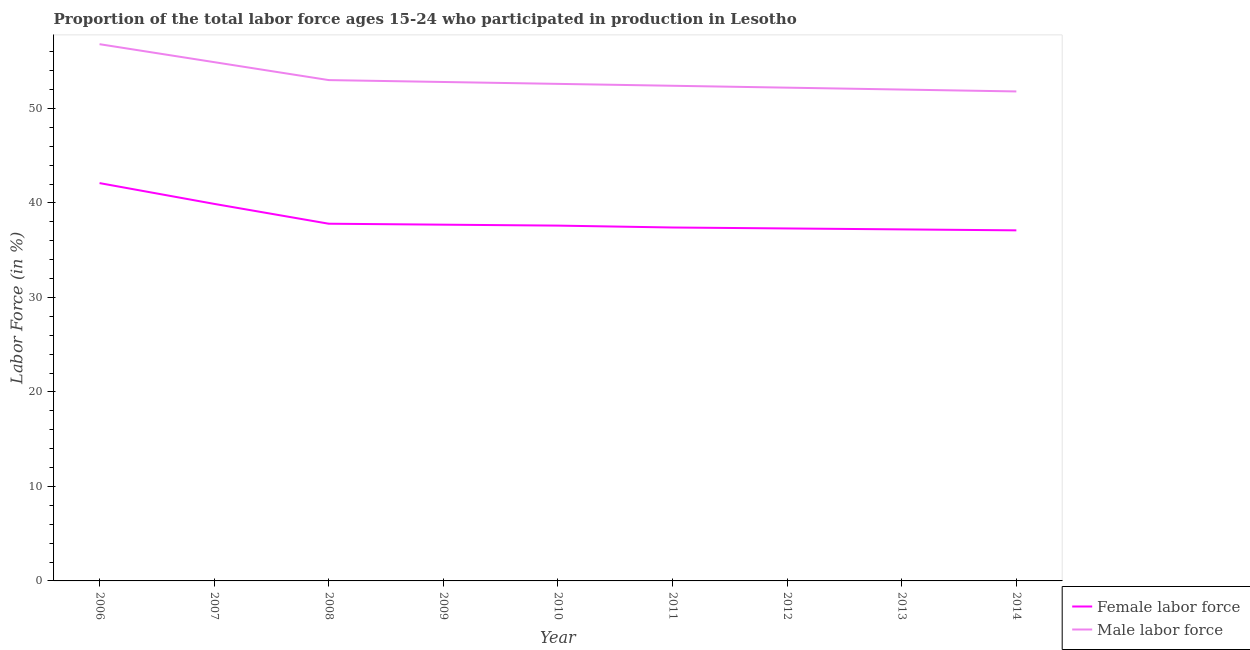Does the line corresponding to percentage of male labour force intersect with the line corresponding to percentage of female labor force?
Keep it short and to the point. No. What is the percentage of female labor force in 2010?
Your answer should be compact. 37.6. Across all years, what is the maximum percentage of female labor force?
Make the answer very short. 42.1. Across all years, what is the minimum percentage of female labor force?
Your answer should be compact. 37.1. In which year was the percentage of female labor force minimum?
Provide a short and direct response. 2014. What is the total percentage of male labour force in the graph?
Make the answer very short. 478.5. What is the difference between the percentage of male labour force in 2006 and that in 2011?
Provide a succinct answer. 4.4. What is the difference between the percentage of female labor force in 2011 and the percentage of male labour force in 2012?
Offer a terse response. -14.8. What is the average percentage of male labour force per year?
Provide a succinct answer. 53.17. In the year 2009, what is the difference between the percentage of male labour force and percentage of female labor force?
Your answer should be very brief. 15.1. In how many years, is the percentage of male labour force greater than 46 %?
Your answer should be very brief. 9. What is the ratio of the percentage of female labor force in 2010 to that in 2012?
Offer a very short reply. 1.01. Is the percentage of male labour force in 2008 less than that in 2010?
Make the answer very short. No. Is the difference between the percentage of male labour force in 2008 and 2013 greater than the difference between the percentage of female labor force in 2008 and 2013?
Your answer should be very brief. Yes. What is the difference between the highest and the second highest percentage of female labor force?
Offer a terse response. 2.2. How many years are there in the graph?
Offer a terse response. 9. Are the values on the major ticks of Y-axis written in scientific E-notation?
Offer a terse response. No. Does the graph contain any zero values?
Provide a succinct answer. No. Does the graph contain grids?
Your answer should be compact. No. Where does the legend appear in the graph?
Your response must be concise. Bottom right. What is the title of the graph?
Offer a terse response. Proportion of the total labor force ages 15-24 who participated in production in Lesotho. What is the label or title of the X-axis?
Keep it short and to the point. Year. What is the label or title of the Y-axis?
Provide a short and direct response. Labor Force (in %). What is the Labor Force (in %) of Female labor force in 2006?
Offer a very short reply. 42.1. What is the Labor Force (in %) of Male labor force in 2006?
Provide a succinct answer. 56.8. What is the Labor Force (in %) of Female labor force in 2007?
Provide a succinct answer. 39.9. What is the Labor Force (in %) in Male labor force in 2007?
Ensure brevity in your answer.  54.9. What is the Labor Force (in %) in Female labor force in 2008?
Make the answer very short. 37.8. What is the Labor Force (in %) in Male labor force in 2008?
Provide a succinct answer. 53. What is the Labor Force (in %) of Female labor force in 2009?
Make the answer very short. 37.7. What is the Labor Force (in %) of Male labor force in 2009?
Your response must be concise. 52.8. What is the Labor Force (in %) in Female labor force in 2010?
Make the answer very short. 37.6. What is the Labor Force (in %) in Male labor force in 2010?
Give a very brief answer. 52.6. What is the Labor Force (in %) in Female labor force in 2011?
Keep it short and to the point. 37.4. What is the Labor Force (in %) of Male labor force in 2011?
Provide a short and direct response. 52.4. What is the Labor Force (in %) of Female labor force in 2012?
Your answer should be compact. 37.3. What is the Labor Force (in %) in Male labor force in 2012?
Ensure brevity in your answer.  52.2. What is the Labor Force (in %) in Female labor force in 2013?
Ensure brevity in your answer.  37.2. What is the Labor Force (in %) in Female labor force in 2014?
Provide a short and direct response. 37.1. What is the Labor Force (in %) in Male labor force in 2014?
Offer a terse response. 51.8. Across all years, what is the maximum Labor Force (in %) of Female labor force?
Keep it short and to the point. 42.1. Across all years, what is the maximum Labor Force (in %) of Male labor force?
Your answer should be very brief. 56.8. Across all years, what is the minimum Labor Force (in %) in Female labor force?
Keep it short and to the point. 37.1. Across all years, what is the minimum Labor Force (in %) of Male labor force?
Provide a short and direct response. 51.8. What is the total Labor Force (in %) of Female labor force in the graph?
Make the answer very short. 344.1. What is the total Labor Force (in %) in Male labor force in the graph?
Ensure brevity in your answer.  478.5. What is the difference between the Labor Force (in %) of Female labor force in 2006 and that in 2007?
Your answer should be compact. 2.2. What is the difference between the Labor Force (in %) of Male labor force in 2006 and that in 2007?
Your response must be concise. 1.9. What is the difference between the Labor Force (in %) of Male labor force in 2006 and that in 2008?
Offer a very short reply. 3.8. What is the difference between the Labor Force (in %) of Male labor force in 2006 and that in 2009?
Your answer should be compact. 4. What is the difference between the Labor Force (in %) in Male labor force in 2006 and that in 2012?
Provide a short and direct response. 4.6. What is the difference between the Labor Force (in %) of Male labor force in 2006 and that in 2013?
Provide a succinct answer. 4.8. What is the difference between the Labor Force (in %) of Female labor force in 2006 and that in 2014?
Your response must be concise. 5. What is the difference between the Labor Force (in %) of Male labor force in 2007 and that in 2008?
Ensure brevity in your answer.  1.9. What is the difference between the Labor Force (in %) of Female labor force in 2007 and that in 2010?
Your answer should be very brief. 2.3. What is the difference between the Labor Force (in %) of Male labor force in 2007 and that in 2010?
Your answer should be compact. 2.3. What is the difference between the Labor Force (in %) in Male labor force in 2007 and that in 2011?
Offer a very short reply. 2.5. What is the difference between the Labor Force (in %) of Female labor force in 2007 and that in 2012?
Make the answer very short. 2.6. What is the difference between the Labor Force (in %) of Female labor force in 2007 and that in 2013?
Provide a short and direct response. 2.7. What is the difference between the Labor Force (in %) of Male labor force in 2007 and that in 2013?
Provide a short and direct response. 2.9. What is the difference between the Labor Force (in %) of Male labor force in 2007 and that in 2014?
Ensure brevity in your answer.  3.1. What is the difference between the Labor Force (in %) in Female labor force in 2008 and that in 2009?
Your answer should be very brief. 0.1. What is the difference between the Labor Force (in %) of Male labor force in 2008 and that in 2009?
Ensure brevity in your answer.  0.2. What is the difference between the Labor Force (in %) of Female labor force in 2008 and that in 2010?
Provide a succinct answer. 0.2. What is the difference between the Labor Force (in %) in Male labor force in 2008 and that in 2011?
Make the answer very short. 0.6. What is the difference between the Labor Force (in %) of Female labor force in 2008 and that in 2012?
Make the answer very short. 0.5. What is the difference between the Labor Force (in %) of Male labor force in 2008 and that in 2014?
Your response must be concise. 1.2. What is the difference between the Labor Force (in %) in Female labor force in 2009 and that in 2011?
Make the answer very short. 0.3. What is the difference between the Labor Force (in %) of Female labor force in 2009 and that in 2012?
Provide a succinct answer. 0.4. What is the difference between the Labor Force (in %) in Female labor force in 2009 and that in 2013?
Your answer should be very brief. 0.5. What is the difference between the Labor Force (in %) in Female labor force in 2009 and that in 2014?
Ensure brevity in your answer.  0.6. What is the difference between the Labor Force (in %) of Male labor force in 2009 and that in 2014?
Provide a short and direct response. 1. What is the difference between the Labor Force (in %) in Female labor force in 2010 and that in 2011?
Give a very brief answer. 0.2. What is the difference between the Labor Force (in %) in Female labor force in 2010 and that in 2013?
Your response must be concise. 0.4. What is the difference between the Labor Force (in %) in Male labor force in 2010 and that in 2013?
Your answer should be compact. 0.6. What is the difference between the Labor Force (in %) of Male labor force in 2011 and that in 2012?
Your answer should be very brief. 0.2. What is the difference between the Labor Force (in %) in Male labor force in 2011 and that in 2013?
Make the answer very short. 0.4. What is the difference between the Labor Force (in %) in Female labor force in 2011 and that in 2014?
Offer a very short reply. 0.3. What is the difference between the Labor Force (in %) of Male labor force in 2012 and that in 2013?
Give a very brief answer. 0.2. What is the difference between the Labor Force (in %) in Female labor force in 2013 and that in 2014?
Offer a terse response. 0.1. What is the difference between the Labor Force (in %) in Female labor force in 2006 and the Labor Force (in %) in Male labor force in 2007?
Keep it short and to the point. -12.8. What is the difference between the Labor Force (in %) of Female labor force in 2006 and the Labor Force (in %) of Male labor force in 2008?
Keep it short and to the point. -10.9. What is the difference between the Labor Force (in %) in Female labor force in 2006 and the Labor Force (in %) in Male labor force in 2011?
Make the answer very short. -10.3. What is the difference between the Labor Force (in %) in Female labor force in 2006 and the Labor Force (in %) in Male labor force in 2013?
Provide a succinct answer. -9.9. What is the difference between the Labor Force (in %) of Female labor force in 2006 and the Labor Force (in %) of Male labor force in 2014?
Your response must be concise. -9.7. What is the difference between the Labor Force (in %) of Female labor force in 2007 and the Labor Force (in %) of Male labor force in 2008?
Offer a terse response. -13.1. What is the difference between the Labor Force (in %) of Female labor force in 2007 and the Labor Force (in %) of Male labor force in 2009?
Keep it short and to the point. -12.9. What is the difference between the Labor Force (in %) of Female labor force in 2007 and the Labor Force (in %) of Male labor force in 2012?
Provide a succinct answer. -12.3. What is the difference between the Labor Force (in %) in Female labor force in 2007 and the Labor Force (in %) in Male labor force in 2013?
Give a very brief answer. -12.1. What is the difference between the Labor Force (in %) of Female labor force in 2008 and the Labor Force (in %) of Male labor force in 2009?
Keep it short and to the point. -15. What is the difference between the Labor Force (in %) of Female labor force in 2008 and the Labor Force (in %) of Male labor force in 2010?
Your answer should be very brief. -14.8. What is the difference between the Labor Force (in %) of Female labor force in 2008 and the Labor Force (in %) of Male labor force in 2011?
Give a very brief answer. -14.6. What is the difference between the Labor Force (in %) of Female labor force in 2008 and the Labor Force (in %) of Male labor force in 2012?
Your response must be concise. -14.4. What is the difference between the Labor Force (in %) of Female labor force in 2008 and the Labor Force (in %) of Male labor force in 2013?
Provide a succinct answer. -14.2. What is the difference between the Labor Force (in %) in Female labor force in 2009 and the Labor Force (in %) in Male labor force in 2010?
Your response must be concise. -14.9. What is the difference between the Labor Force (in %) in Female labor force in 2009 and the Labor Force (in %) in Male labor force in 2011?
Your answer should be compact. -14.7. What is the difference between the Labor Force (in %) of Female labor force in 2009 and the Labor Force (in %) of Male labor force in 2013?
Keep it short and to the point. -14.3. What is the difference between the Labor Force (in %) in Female labor force in 2009 and the Labor Force (in %) in Male labor force in 2014?
Your answer should be compact. -14.1. What is the difference between the Labor Force (in %) in Female labor force in 2010 and the Labor Force (in %) in Male labor force in 2011?
Keep it short and to the point. -14.8. What is the difference between the Labor Force (in %) in Female labor force in 2010 and the Labor Force (in %) in Male labor force in 2012?
Your response must be concise. -14.6. What is the difference between the Labor Force (in %) in Female labor force in 2010 and the Labor Force (in %) in Male labor force in 2013?
Offer a terse response. -14.4. What is the difference between the Labor Force (in %) in Female labor force in 2010 and the Labor Force (in %) in Male labor force in 2014?
Provide a succinct answer. -14.2. What is the difference between the Labor Force (in %) in Female labor force in 2011 and the Labor Force (in %) in Male labor force in 2012?
Provide a short and direct response. -14.8. What is the difference between the Labor Force (in %) of Female labor force in 2011 and the Labor Force (in %) of Male labor force in 2013?
Ensure brevity in your answer.  -14.6. What is the difference between the Labor Force (in %) in Female labor force in 2011 and the Labor Force (in %) in Male labor force in 2014?
Offer a very short reply. -14.4. What is the difference between the Labor Force (in %) in Female labor force in 2012 and the Labor Force (in %) in Male labor force in 2013?
Give a very brief answer. -14.7. What is the difference between the Labor Force (in %) of Female labor force in 2013 and the Labor Force (in %) of Male labor force in 2014?
Your response must be concise. -14.6. What is the average Labor Force (in %) of Female labor force per year?
Your answer should be compact. 38.23. What is the average Labor Force (in %) of Male labor force per year?
Keep it short and to the point. 53.17. In the year 2006, what is the difference between the Labor Force (in %) in Female labor force and Labor Force (in %) in Male labor force?
Give a very brief answer. -14.7. In the year 2007, what is the difference between the Labor Force (in %) of Female labor force and Labor Force (in %) of Male labor force?
Provide a short and direct response. -15. In the year 2008, what is the difference between the Labor Force (in %) in Female labor force and Labor Force (in %) in Male labor force?
Your answer should be compact. -15.2. In the year 2009, what is the difference between the Labor Force (in %) in Female labor force and Labor Force (in %) in Male labor force?
Your response must be concise. -15.1. In the year 2010, what is the difference between the Labor Force (in %) in Female labor force and Labor Force (in %) in Male labor force?
Make the answer very short. -15. In the year 2012, what is the difference between the Labor Force (in %) in Female labor force and Labor Force (in %) in Male labor force?
Ensure brevity in your answer.  -14.9. In the year 2013, what is the difference between the Labor Force (in %) of Female labor force and Labor Force (in %) of Male labor force?
Your answer should be very brief. -14.8. In the year 2014, what is the difference between the Labor Force (in %) of Female labor force and Labor Force (in %) of Male labor force?
Your answer should be very brief. -14.7. What is the ratio of the Labor Force (in %) of Female labor force in 2006 to that in 2007?
Your response must be concise. 1.06. What is the ratio of the Labor Force (in %) of Male labor force in 2006 to that in 2007?
Offer a terse response. 1.03. What is the ratio of the Labor Force (in %) in Female labor force in 2006 to that in 2008?
Ensure brevity in your answer.  1.11. What is the ratio of the Labor Force (in %) of Male labor force in 2006 to that in 2008?
Your answer should be compact. 1.07. What is the ratio of the Labor Force (in %) of Female labor force in 2006 to that in 2009?
Keep it short and to the point. 1.12. What is the ratio of the Labor Force (in %) in Male labor force in 2006 to that in 2009?
Provide a short and direct response. 1.08. What is the ratio of the Labor Force (in %) of Female labor force in 2006 to that in 2010?
Give a very brief answer. 1.12. What is the ratio of the Labor Force (in %) of Male labor force in 2006 to that in 2010?
Keep it short and to the point. 1.08. What is the ratio of the Labor Force (in %) in Female labor force in 2006 to that in 2011?
Keep it short and to the point. 1.13. What is the ratio of the Labor Force (in %) in Male labor force in 2006 to that in 2011?
Provide a short and direct response. 1.08. What is the ratio of the Labor Force (in %) of Female labor force in 2006 to that in 2012?
Offer a terse response. 1.13. What is the ratio of the Labor Force (in %) in Male labor force in 2006 to that in 2012?
Make the answer very short. 1.09. What is the ratio of the Labor Force (in %) in Female labor force in 2006 to that in 2013?
Offer a terse response. 1.13. What is the ratio of the Labor Force (in %) in Male labor force in 2006 to that in 2013?
Offer a terse response. 1.09. What is the ratio of the Labor Force (in %) in Female labor force in 2006 to that in 2014?
Your answer should be compact. 1.13. What is the ratio of the Labor Force (in %) of Male labor force in 2006 to that in 2014?
Give a very brief answer. 1.1. What is the ratio of the Labor Force (in %) of Female labor force in 2007 to that in 2008?
Your response must be concise. 1.06. What is the ratio of the Labor Force (in %) in Male labor force in 2007 to that in 2008?
Your answer should be very brief. 1.04. What is the ratio of the Labor Force (in %) in Female labor force in 2007 to that in 2009?
Provide a short and direct response. 1.06. What is the ratio of the Labor Force (in %) of Male labor force in 2007 to that in 2009?
Provide a short and direct response. 1.04. What is the ratio of the Labor Force (in %) of Female labor force in 2007 to that in 2010?
Your answer should be compact. 1.06. What is the ratio of the Labor Force (in %) of Male labor force in 2007 to that in 2010?
Keep it short and to the point. 1.04. What is the ratio of the Labor Force (in %) of Female labor force in 2007 to that in 2011?
Offer a very short reply. 1.07. What is the ratio of the Labor Force (in %) in Male labor force in 2007 to that in 2011?
Keep it short and to the point. 1.05. What is the ratio of the Labor Force (in %) of Female labor force in 2007 to that in 2012?
Offer a terse response. 1.07. What is the ratio of the Labor Force (in %) of Male labor force in 2007 to that in 2012?
Your answer should be very brief. 1.05. What is the ratio of the Labor Force (in %) in Female labor force in 2007 to that in 2013?
Your answer should be compact. 1.07. What is the ratio of the Labor Force (in %) in Male labor force in 2007 to that in 2013?
Offer a terse response. 1.06. What is the ratio of the Labor Force (in %) in Female labor force in 2007 to that in 2014?
Keep it short and to the point. 1.08. What is the ratio of the Labor Force (in %) of Male labor force in 2007 to that in 2014?
Ensure brevity in your answer.  1.06. What is the ratio of the Labor Force (in %) of Female labor force in 2008 to that in 2009?
Make the answer very short. 1. What is the ratio of the Labor Force (in %) of Male labor force in 2008 to that in 2009?
Your answer should be very brief. 1. What is the ratio of the Labor Force (in %) of Male labor force in 2008 to that in 2010?
Offer a terse response. 1.01. What is the ratio of the Labor Force (in %) of Female labor force in 2008 to that in 2011?
Offer a terse response. 1.01. What is the ratio of the Labor Force (in %) of Male labor force in 2008 to that in 2011?
Your answer should be compact. 1.01. What is the ratio of the Labor Force (in %) of Female labor force in 2008 to that in 2012?
Keep it short and to the point. 1.01. What is the ratio of the Labor Force (in %) in Male labor force in 2008 to that in 2012?
Offer a very short reply. 1.02. What is the ratio of the Labor Force (in %) in Female labor force in 2008 to that in 2013?
Your response must be concise. 1.02. What is the ratio of the Labor Force (in %) in Male labor force in 2008 to that in 2013?
Your answer should be very brief. 1.02. What is the ratio of the Labor Force (in %) in Female labor force in 2008 to that in 2014?
Ensure brevity in your answer.  1.02. What is the ratio of the Labor Force (in %) in Male labor force in 2008 to that in 2014?
Keep it short and to the point. 1.02. What is the ratio of the Labor Force (in %) of Female labor force in 2009 to that in 2010?
Keep it short and to the point. 1. What is the ratio of the Labor Force (in %) in Male labor force in 2009 to that in 2010?
Offer a terse response. 1. What is the ratio of the Labor Force (in %) in Male labor force in 2009 to that in 2011?
Make the answer very short. 1.01. What is the ratio of the Labor Force (in %) in Female labor force in 2009 to that in 2012?
Keep it short and to the point. 1.01. What is the ratio of the Labor Force (in %) of Male labor force in 2009 to that in 2012?
Ensure brevity in your answer.  1.01. What is the ratio of the Labor Force (in %) in Female labor force in 2009 to that in 2013?
Provide a short and direct response. 1.01. What is the ratio of the Labor Force (in %) in Male labor force in 2009 to that in 2013?
Ensure brevity in your answer.  1.02. What is the ratio of the Labor Force (in %) of Female labor force in 2009 to that in 2014?
Offer a terse response. 1.02. What is the ratio of the Labor Force (in %) in Male labor force in 2009 to that in 2014?
Provide a short and direct response. 1.02. What is the ratio of the Labor Force (in %) in Female labor force in 2010 to that in 2012?
Give a very brief answer. 1.01. What is the ratio of the Labor Force (in %) of Male labor force in 2010 to that in 2012?
Your response must be concise. 1.01. What is the ratio of the Labor Force (in %) of Female labor force in 2010 to that in 2013?
Keep it short and to the point. 1.01. What is the ratio of the Labor Force (in %) in Male labor force in 2010 to that in 2013?
Make the answer very short. 1.01. What is the ratio of the Labor Force (in %) in Female labor force in 2010 to that in 2014?
Your answer should be compact. 1.01. What is the ratio of the Labor Force (in %) of Male labor force in 2010 to that in 2014?
Offer a very short reply. 1.02. What is the ratio of the Labor Force (in %) in Female labor force in 2011 to that in 2012?
Your answer should be compact. 1. What is the ratio of the Labor Force (in %) in Female labor force in 2011 to that in 2013?
Provide a succinct answer. 1.01. What is the ratio of the Labor Force (in %) in Male labor force in 2011 to that in 2013?
Provide a short and direct response. 1.01. What is the ratio of the Labor Force (in %) in Female labor force in 2011 to that in 2014?
Your answer should be very brief. 1.01. What is the ratio of the Labor Force (in %) in Male labor force in 2011 to that in 2014?
Make the answer very short. 1.01. What is the ratio of the Labor Force (in %) of Female labor force in 2012 to that in 2013?
Offer a terse response. 1. What is the ratio of the Labor Force (in %) in Male labor force in 2012 to that in 2013?
Provide a succinct answer. 1. What is the ratio of the Labor Force (in %) of Female labor force in 2012 to that in 2014?
Your response must be concise. 1.01. What is the ratio of the Labor Force (in %) of Male labor force in 2012 to that in 2014?
Give a very brief answer. 1.01. What is the ratio of the Labor Force (in %) in Male labor force in 2013 to that in 2014?
Provide a short and direct response. 1. What is the difference between the highest and the second highest Labor Force (in %) of Female labor force?
Make the answer very short. 2.2. 